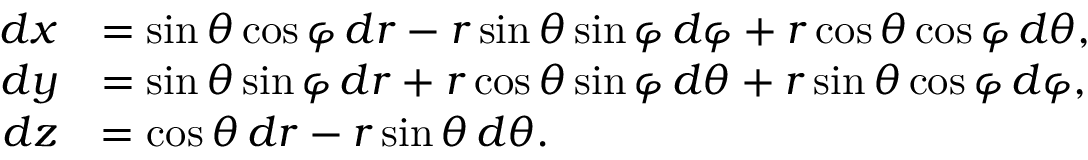Convert formula to latex. <formula><loc_0><loc_0><loc_500><loc_500>\begin{array} { r l } { d x } & { = \sin \theta \cos \varphi \, d r - r \sin \theta \sin \varphi \, d \varphi + r \cos \theta \cos \varphi \, d \theta , } \\ { d y } & { = \sin \theta \sin \varphi \, d r + r \cos \theta \sin \varphi \, d \theta + r \sin \theta \cos \varphi \, d \varphi , } \\ { d z } & { = \cos \theta \, d r - r \sin \theta \, d \theta . } \end{array}</formula> 